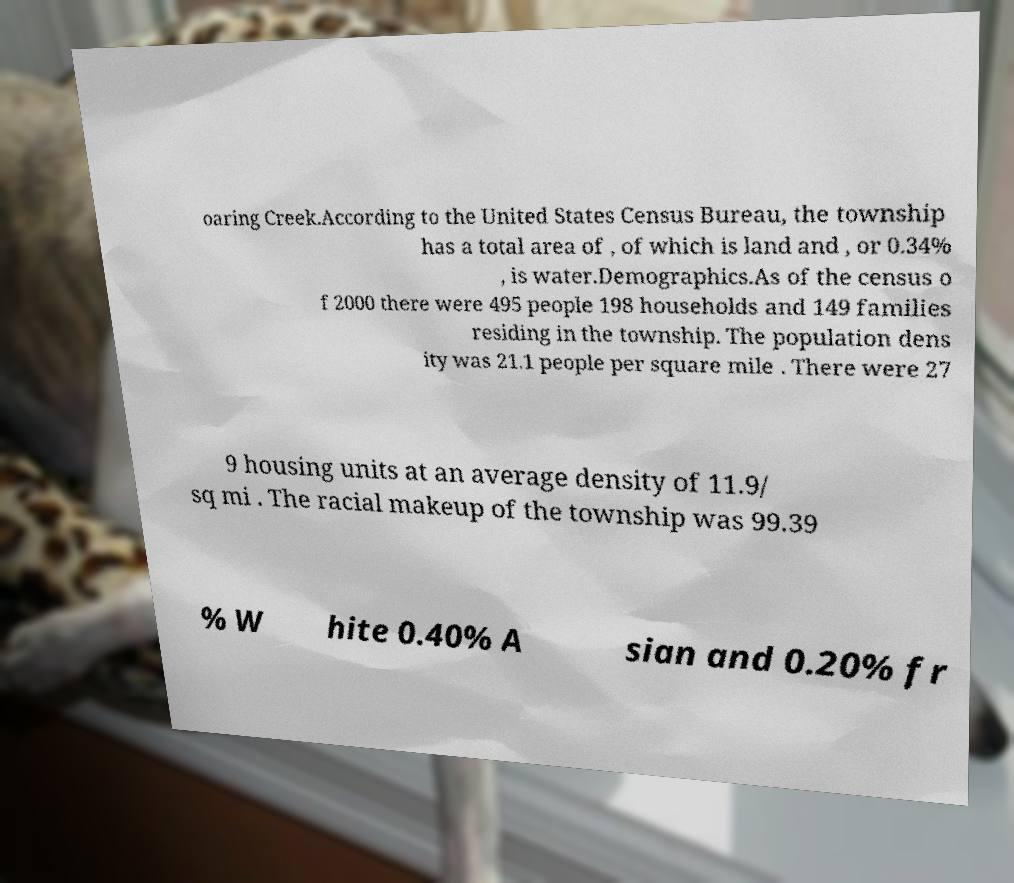For documentation purposes, I need the text within this image transcribed. Could you provide that? oaring Creek.According to the United States Census Bureau, the township has a total area of , of which is land and , or 0.34% , is water.Demographics.As of the census o f 2000 there were 495 people 198 households and 149 families residing in the township. The population dens ity was 21.1 people per square mile . There were 27 9 housing units at an average density of 11.9/ sq mi . The racial makeup of the township was 99.39 % W hite 0.40% A sian and 0.20% fr 